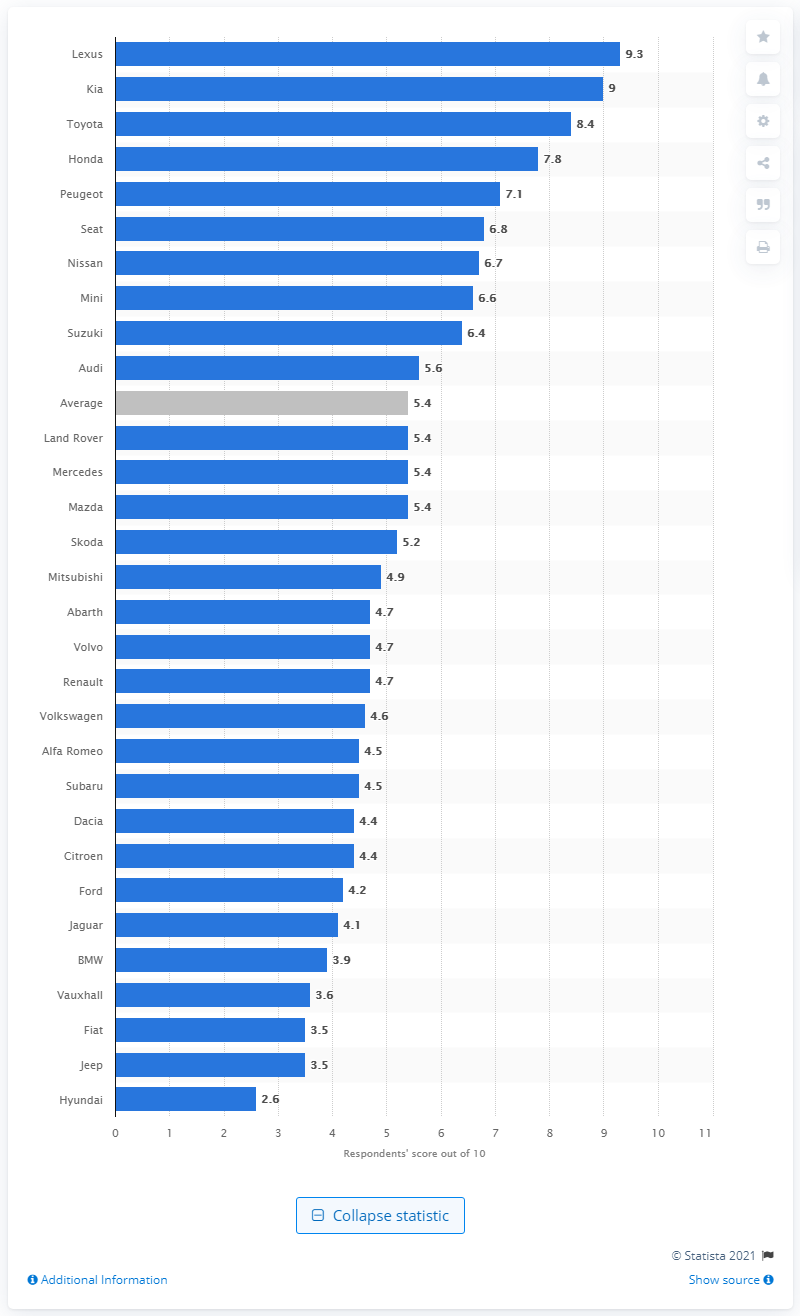Highlight a few significant elements in this photo. The Lexus dealership received the highest score of 9.3 out of 10 from customers. The highest score given to Lexus dealers was 9.3. 